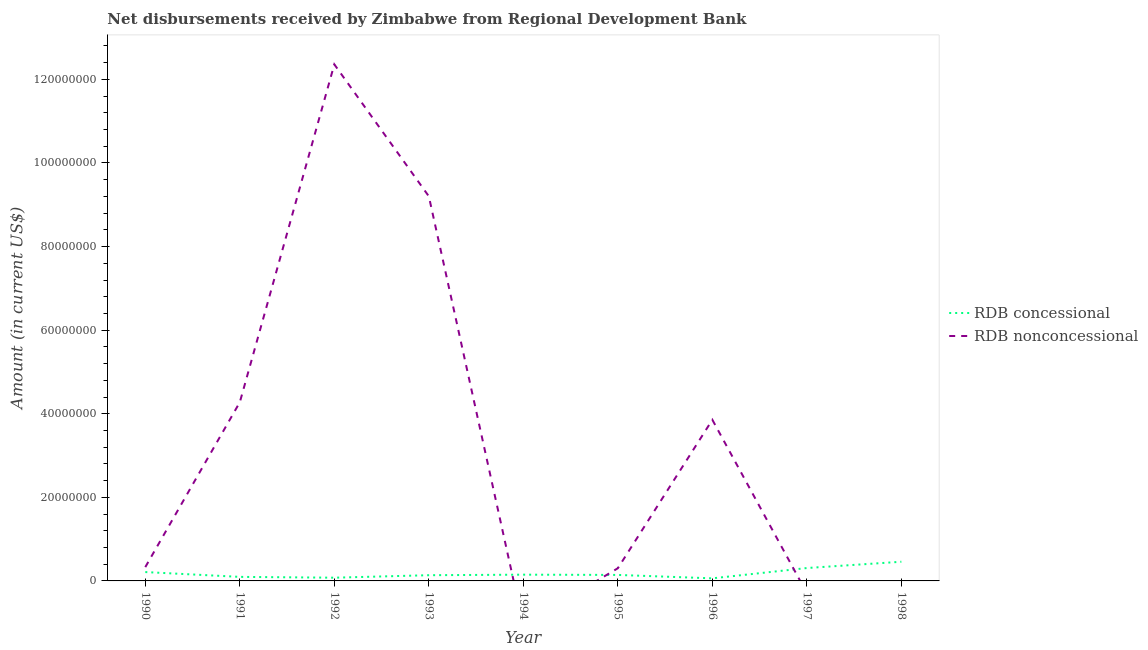How many different coloured lines are there?
Your answer should be compact. 2. Does the line corresponding to net concessional disbursements from rdb intersect with the line corresponding to net non concessional disbursements from rdb?
Provide a short and direct response. Yes. Is the number of lines equal to the number of legend labels?
Ensure brevity in your answer.  No. What is the net non concessional disbursements from rdb in 1990?
Your answer should be very brief. 3.30e+06. Across all years, what is the maximum net non concessional disbursements from rdb?
Give a very brief answer. 1.24e+08. What is the total net concessional disbursements from rdb in the graph?
Your answer should be very brief. 1.64e+07. What is the difference between the net non concessional disbursements from rdb in 1992 and that in 1995?
Your response must be concise. 1.21e+08. What is the difference between the net concessional disbursements from rdb in 1997 and the net non concessional disbursements from rdb in 1998?
Your answer should be compact. 3.08e+06. What is the average net concessional disbursements from rdb per year?
Ensure brevity in your answer.  1.83e+06. In the year 1991, what is the difference between the net non concessional disbursements from rdb and net concessional disbursements from rdb?
Provide a short and direct response. 4.18e+07. What is the ratio of the net non concessional disbursements from rdb in 1990 to that in 1993?
Offer a terse response. 0.04. Is the difference between the net concessional disbursements from rdb in 1990 and 1996 greater than the difference between the net non concessional disbursements from rdb in 1990 and 1996?
Make the answer very short. Yes. What is the difference between the highest and the second highest net non concessional disbursements from rdb?
Ensure brevity in your answer.  3.16e+07. What is the difference between the highest and the lowest net concessional disbursements from rdb?
Provide a succinct answer. 3.97e+06. In how many years, is the net non concessional disbursements from rdb greater than the average net non concessional disbursements from rdb taken over all years?
Give a very brief answer. 4. Is the net non concessional disbursements from rdb strictly less than the net concessional disbursements from rdb over the years?
Offer a terse response. No. How many lines are there?
Offer a terse response. 2. How many years are there in the graph?
Make the answer very short. 9. What is the difference between two consecutive major ticks on the Y-axis?
Offer a very short reply. 2.00e+07. Does the graph contain grids?
Keep it short and to the point. No. Where does the legend appear in the graph?
Give a very brief answer. Center right. How are the legend labels stacked?
Your response must be concise. Vertical. What is the title of the graph?
Provide a succinct answer. Net disbursements received by Zimbabwe from Regional Development Bank. Does "Nitrous oxide" appear as one of the legend labels in the graph?
Provide a short and direct response. No. What is the label or title of the X-axis?
Give a very brief answer. Year. What is the label or title of the Y-axis?
Your response must be concise. Amount (in current US$). What is the Amount (in current US$) of RDB concessional in 1990?
Your answer should be compact. 2.12e+06. What is the Amount (in current US$) of RDB nonconcessional in 1990?
Offer a terse response. 3.30e+06. What is the Amount (in current US$) of RDB concessional in 1991?
Your answer should be compact. 9.67e+05. What is the Amount (in current US$) in RDB nonconcessional in 1991?
Offer a terse response. 4.27e+07. What is the Amount (in current US$) of RDB concessional in 1992?
Provide a short and direct response. 7.71e+05. What is the Amount (in current US$) in RDB nonconcessional in 1992?
Offer a terse response. 1.24e+08. What is the Amount (in current US$) in RDB concessional in 1993?
Offer a very short reply. 1.37e+06. What is the Amount (in current US$) in RDB nonconcessional in 1993?
Make the answer very short. 9.20e+07. What is the Amount (in current US$) of RDB concessional in 1994?
Give a very brief answer. 1.50e+06. What is the Amount (in current US$) of RDB nonconcessional in 1994?
Keep it short and to the point. 0. What is the Amount (in current US$) in RDB concessional in 1995?
Offer a very short reply. 1.43e+06. What is the Amount (in current US$) of RDB nonconcessional in 1995?
Provide a succinct answer. 3.04e+06. What is the Amount (in current US$) in RDB concessional in 1996?
Make the answer very short. 6.17e+05. What is the Amount (in current US$) in RDB nonconcessional in 1996?
Your response must be concise. 3.86e+07. What is the Amount (in current US$) in RDB concessional in 1997?
Your response must be concise. 3.08e+06. What is the Amount (in current US$) in RDB concessional in 1998?
Give a very brief answer. 4.59e+06. What is the Amount (in current US$) of RDB nonconcessional in 1998?
Provide a short and direct response. 0. Across all years, what is the maximum Amount (in current US$) in RDB concessional?
Offer a terse response. 4.59e+06. Across all years, what is the maximum Amount (in current US$) in RDB nonconcessional?
Provide a short and direct response. 1.24e+08. Across all years, what is the minimum Amount (in current US$) of RDB concessional?
Ensure brevity in your answer.  6.17e+05. What is the total Amount (in current US$) of RDB concessional in the graph?
Your answer should be compact. 1.64e+07. What is the total Amount (in current US$) of RDB nonconcessional in the graph?
Keep it short and to the point. 3.03e+08. What is the difference between the Amount (in current US$) of RDB concessional in 1990 and that in 1991?
Provide a succinct answer. 1.15e+06. What is the difference between the Amount (in current US$) of RDB nonconcessional in 1990 and that in 1991?
Provide a short and direct response. -3.94e+07. What is the difference between the Amount (in current US$) in RDB concessional in 1990 and that in 1992?
Provide a succinct answer. 1.35e+06. What is the difference between the Amount (in current US$) of RDB nonconcessional in 1990 and that in 1992?
Keep it short and to the point. -1.20e+08. What is the difference between the Amount (in current US$) of RDB concessional in 1990 and that in 1993?
Offer a very short reply. 7.51e+05. What is the difference between the Amount (in current US$) of RDB nonconcessional in 1990 and that in 1993?
Your response must be concise. -8.87e+07. What is the difference between the Amount (in current US$) of RDB concessional in 1990 and that in 1994?
Make the answer very short. 6.24e+05. What is the difference between the Amount (in current US$) of RDB concessional in 1990 and that in 1995?
Your answer should be compact. 6.86e+05. What is the difference between the Amount (in current US$) in RDB nonconcessional in 1990 and that in 1995?
Make the answer very short. 2.67e+05. What is the difference between the Amount (in current US$) of RDB concessional in 1990 and that in 1996?
Your answer should be compact. 1.50e+06. What is the difference between the Amount (in current US$) in RDB nonconcessional in 1990 and that in 1996?
Your response must be concise. -3.52e+07. What is the difference between the Amount (in current US$) in RDB concessional in 1990 and that in 1997?
Provide a succinct answer. -9.65e+05. What is the difference between the Amount (in current US$) in RDB concessional in 1990 and that in 1998?
Your response must be concise. -2.47e+06. What is the difference between the Amount (in current US$) in RDB concessional in 1991 and that in 1992?
Offer a terse response. 1.96e+05. What is the difference between the Amount (in current US$) of RDB nonconcessional in 1991 and that in 1992?
Your response must be concise. -8.08e+07. What is the difference between the Amount (in current US$) in RDB concessional in 1991 and that in 1993?
Your answer should be compact. -4.02e+05. What is the difference between the Amount (in current US$) in RDB nonconcessional in 1991 and that in 1993?
Offer a terse response. -4.93e+07. What is the difference between the Amount (in current US$) of RDB concessional in 1991 and that in 1994?
Your answer should be very brief. -5.29e+05. What is the difference between the Amount (in current US$) in RDB concessional in 1991 and that in 1995?
Your answer should be compact. -4.67e+05. What is the difference between the Amount (in current US$) of RDB nonconcessional in 1991 and that in 1995?
Make the answer very short. 3.97e+07. What is the difference between the Amount (in current US$) of RDB nonconcessional in 1991 and that in 1996?
Provide a short and direct response. 4.20e+06. What is the difference between the Amount (in current US$) in RDB concessional in 1991 and that in 1997?
Your answer should be very brief. -2.12e+06. What is the difference between the Amount (in current US$) of RDB concessional in 1991 and that in 1998?
Make the answer very short. -3.62e+06. What is the difference between the Amount (in current US$) of RDB concessional in 1992 and that in 1993?
Make the answer very short. -5.98e+05. What is the difference between the Amount (in current US$) of RDB nonconcessional in 1992 and that in 1993?
Provide a short and direct response. 3.16e+07. What is the difference between the Amount (in current US$) in RDB concessional in 1992 and that in 1994?
Your answer should be compact. -7.25e+05. What is the difference between the Amount (in current US$) of RDB concessional in 1992 and that in 1995?
Give a very brief answer. -6.63e+05. What is the difference between the Amount (in current US$) of RDB nonconcessional in 1992 and that in 1995?
Keep it short and to the point. 1.21e+08. What is the difference between the Amount (in current US$) in RDB concessional in 1992 and that in 1996?
Make the answer very short. 1.54e+05. What is the difference between the Amount (in current US$) of RDB nonconcessional in 1992 and that in 1996?
Provide a short and direct response. 8.50e+07. What is the difference between the Amount (in current US$) in RDB concessional in 1992 and that in 1997?
Give a very brief answer. -2.31e+06. What is the difference between the Amount (in current US$) of RDB concessional in 1992 and that in 1998?
Keep it short and to the point. -3.82e+06. What is the difference between the Amount (in current US$) in RDB concessional in 1993 and that in 1994?
Offer a terse response. -1.27e+05. What is the difference between the Amount (in current US$) of RDB concessional in 1993 and that in 1995?
Your response must be concise. -6.50e+04. What is the difference between the Amount (in current US$) in RDB nonconcessional in 1993 and that in 1995?
Provide a succinct answer. 8.90e+07. What is the difference between the Amount (in current US$) of RDB concessional in 1993 and that in 1996?
Keep it short and to the point. 7.52e+05. What is the difference between the Amount (in current US$) in RDB nonconcessional in 1993 and that in 1996?
Your answer should be very brief. 5.35e+07. What is the difference between the Amount (in current US$) in RDB concessional in 1993 and that in 1997?
Keep it short and to the point. -1.72e+06. What is the difference between the Amount (in current US$) of RDB concessional in 1993 and that in 1998?
Your response must be concise. -3.22e+06. What is the difference between the Amount (in current US$) in RDB concessional in 1994 and that in 1995?
Your answer should be compact. 6.20e+04. What is the difference between the Amount (in current US$) of RDB concessional in 1994 and that in 1996?
Offer a terse response. 8.79e+05. What is the difference between the Amount (in current US$) in RDB concessional in 1994 and that in 1997?
Keep it short and to the point. -1.59e+06. What is the difference between the Amount (in current US$) in RDB concessional in 1994 and that in 1998?
Your answer should be compact. -3.09e+06. What is the difference between the Amount (in current US$) in RDB concessional in 1995 and that in 1996?
Offer a terse response. 8.17e+05. What is the difference between the Amount (in current US$) of RDB nonconcessional in 1995 and that in 1996?
Your answer should be very brief. -3.55e+07. What is the difference between the Amount (in current US$) in RDB concessional in 1995 and that in 1997?
Keep it short and to the point. -1.65e+06. What is the difference between the Amount (in current US$) in RDB concessional in 1995 and that in 1998?
Provide a short and direct response. -3.16e+06. What is the difference between the Amount (in current US$) of RDB concessional in 1996 and that in 1997?
Offer a terse response. -2.47e+06. What is the difference between the Amount (in current US$) of RDB concessional in 1996 and that in 1998?
Ensure brevity in your answer.  -3.97e+06. What is the difference between the Amount (in current US$) of RDB concessional in 1997 and that in 1998?
Provide a short and direct response. -1.50e+06. What is the difference between the Amount (in current US$) of RDB concessional in 1990 and the Amount (in current US$) of RDB nonconcessional in 1991?
Your answer should be compact. -4.06e+07. What is the difference between the Amount (in current US$) of RDB concessional in 1990 and the Amount (in current US$) of RDB nonconcessional in 1992?
Your response must be concise. -1.21e+08. What is the difference between the Amount (in current US$) of RDB concessional in 1990 and the Amount (in current US$) of RDB nonconcessional in 1993?
Offer a very short reply. -8.99e+07. What is the difference between the Amount (in current US$) in RDB concessional in 1990 and the Amount (in current US$) in RDB nonconcessional in 1995?
Provide a short and direct response. -9.17e+05. What is the difference between the Amount (in current US$) in RDB concessional in 1990 and the Amount (in current US$) in RDB nonconcessional in 1996?
Provide a short and direct response. -3.64e+07. What is the difference between the Amount (in current US$) of RDB concessional in 1991 and the Amount (in current US$) of RDB nonconcessional in 1992?
Provide a succinct answer. -1.23e+08. What is the difference between the Amount (in current US$) in RDB concessional in 1991 and the Amount (in current US$) in RDB nonconcessional in 1993?
Offer a very short reply. -9.11e+07. What is the difference between the Amount (in current US$) in RDB concessional in 1991 and the Amount (in current US$) in RDB nonconcessional in 1995?
Provide a succinct answer. -2.07e+06. What is the difference between the Amount (in current US$) of RDB concessional in 1991 and the Amount (in current US$) of RDB nonconcessional in 1996?
Your answer should be very brief. -3.76e+07. What is the difference between the Amount (in current US$) in RDB concessional in 1992 and the Amount (in current US$) in RDB nonconcessional in 1993?
Your answer should be compact. -9.13e+07. What is the difference between the Amount (in current US$) of RDB concessional in 1992 and the Amount (in current US$) of RDB nonconcessional in 1995?
Your answer should be very brief. -2.27e+06. What is the difference between the Amount (in current US$) in RDB concessional in 1992 and the Amount (in current US$) in RDB nonconcessional in 1996?
Ensure brevity in your answer.  -3.78e+07. What is the difference between the Amount (in current US$) in RDB concessional in 1993 and the Amount (in current US$) in RDB nonconcessional in 1995?
Offer a terse response. -1.67e+06. What is the difference between the Amount (in current US$) of RDB concessional in 1993 and the Amount (in current US$) of RDB nonconcessional in 1996?
Make the answer very short. -3.72e+07. What is the difference between the Amount (in current US$) in RDB concessional in 1994 and the Amount (in current US$) in RDB nonconcessional in 1995?
Keep it short and to the point. -1.54e+06. What is the difference between the Amount (in current US$) in RDB concessional in 1994 and the Amount (in current US$) in RDB nonconcessional in 1996?
Provide a succinct answer. -3.71e+07. What is the difference between the Amount (in current US$) of RDB concessional in 1995 and the Amount (in current US$) of RDB nonconcessional in 1996?
Offer a very short reply. -3.71e+07. What is the average Amount (in current US$) of RDB concessional per year?
Provide a short and direct response. 1.83e+06. What is the average Amount (in current US$) in RDB nonconcessional per year?
Offer a terse response. 3.37e+07. In the year 1990, what is the difference between the Amount (in current US$) of RDB concessional and Amount (in current US$) of RDB nonconcessional?
Your response must be concise. -1.18e+06. In the year 1991, what is the difference between the Amount (in current US$) in RDB concessional and Amount (in current US$) in RDB nonconcessional?
Your answer should be compact. -4.18e+07. In the year 1992, what is the difference between the Amount (in current US$) of RDB concessional and Amount (in current US$) of RDB nonconcessional?
Offer a very short reply. -1.23e+08. In the year 1993, what is the difference between the Amount (in current US$) of RDB concessional and Amount (in current US$) of RDB nonconcessional?
Offer a very short reply. -9.07e+07. In the year 1995, what is the difference between the Amount (in current US$) of RDB concessional and Amount (in current US$) of RDB nonconcessional?
Offer a terse response. -1.60e+06. In the year 1996, what is the difference between the Amount (in current US$) in RDB concessional and Amount (in current US$) in RDB nonconcessional?
Offer a very short reply. -3.79e+07. What is the ratio of the Amount (in current US$) in RDB concessional in 1990 to that in 1991?
Provide a succinct answer. 2.19. What is the ratio of the Amount (in current US$) in RDB nonconcessional in 1990 to that in 1991?
Make the answer very short. 0.08. What is the ratio of the Amount (in current US$) in RDB concessional in 1990 to that in 1992?
Keep it short and to the point. 2.75. What is the ratio of the Amount (in current US$) of RDB nonconcessional in 1990 to that in 1992?
Your answer should be compact. 0.03. What is the ratio of the Amount (in current US$) in RDB concessional in 1990 to that in 1993?
Provide a succinct answer. 1.55. What is the ratio of the Amount (in current US$) in RDB nonconcessional in 1990 to that in 1993?
Keep it short and to the point. 0.04. What is the ratio of the Amount (in current US$) of RDB concessional in 1990 to that in 1994?
Make the answer very short. 1.42. What is the ratio of the Amount (in current US$) of RDB concessional in 1990 to that in 1995?
Your answer should be very brief. 1.48. What is the ratio of the Amount (in current US$) of RDB nonconcessional in 1990 to that in 1995?
Offer a very short reply. 1.09. What is the ratio of the Amount (in current US$) of RDB concessional in 1990 to that in 1996?
Provide a succinct answer. 3.44. What is the ratio of the Amount (in current US$) of RDB nonconcessional in 1990 to that in 1996?
Your response must be concise. 0.09. What is the ratio of the Amount (in current US$) of RDB concessional in 1990 to that in 1997?
Your answer should be very brief. 0.69. What is the ratio of the Amount (in current US$) in RDB concessional in 1990 to that in 1998?
Give a very brief answer. 0.46. What is the ratio of the Amount (in current US$) of RDB concessional in 1991 to that in 1992?
Offer a terse response. 1.25. What is the ratio of the Amount (in current US$) of RDB nonconcessional in 1991 to that in 1992?
Your answer should be compact. 0.35. What is the ratio of the Amount (in current US$) of RDB concessional in 1991 to that in 1993?
Give a very brief answer. 0.71. What is the ratio of the Amount (in current US$) of RDB nonconcessional in 1991 to that in 1993?
Your answer should be compact. 0.46. What is the ratio of the Amount (in current US$) of RDB concessional in 1991 to that in 1994?
Your answer should be very brief. 0.65. What is the ratio of the Amount (in current US$) of RDB concessional in 1991 to that in 1995?
Keep it short and to the point. 0.67. What is the ratio of the Amount (in current US$) in RDB nonconcessional in 1991 to that in 1995?
Give a very brief answer. 14.08. What is the ratio of the Amount (in current US$) in RDB concessional in 1991 to that in 1996?
Provide a short and direct response. 1.57. What is the ratio of the Amount (in current US$) in RDB nonconcessional in 1991 to that in 1996?
Offer a terse response. 1.11. What is the ratio of the Amount (in current US$) in RDB concessional in 1991 to that in 1997?
Keep it short and to the point. 0.31. What is the ratio of the Amount (in current US$) in RDB concessional in 1991 to that in 1998?
Offer a terse response. 0.21. What is the ratio of the Amount (in current US$) in RDB concessional in 1992 to that in 1993?
Make the answer very short. 0.56. What is the ratio of the Amount (in current US$) of RDB nonconcessional in 1992 to that in 1993?
Keep it short and to the point. 1.34. What is the ratio of the Amount (in current US$) in RDB concessional in 1992 to that in 1994?
Ensure brevity in your answer.  0.52. What is the ratio of the Amount (in current US$) in RDB concessional in 1992 to that in 1995?
Offer a very short reply. 0.54. What is the ratio of the Amount (in current US$) of RDB nonconcessional in 1992 to that in 1995?
Keep it short and to the point. 40.7. What is the ratio of the Amount (in current US$) of RDB concessional in 1992 to that in 1996?
Your answer should be compact. 1.25. What is the ratio of the Amount (in current US$) in RDB nonconcessional in 1992 to that in 1996?
Your answer should be very brief. 3.21. What is the ratio of the Amount (in current US$) in RDB concessional in 1992 to that in 1997?
Offer a terse response. 0.25. What is the ratio of the Amount (in current US$) of RDB concessional in 1992 to that in 1998?
Provide a succinct answer. 0.17. What is the ratio of the Amount (in current US$) in RDB concessional in 1993 to that in 1994?
Give a very brief answer. 0.92. What is the ratio of the Amount (in current US$) in RDB concessional in 1993 to that in 1995?
Your answer should be very brief. 0.95. What is the ratio of the Amount (in current US$) of RDB nonconcessional in 1993 to that in 1995?
Offer a very short reply. 30.3. What is the ratio of the Amount (in current US$) in RDB concessional in 1993 to that in 1996?
Give a very brief answer. 2.22. What is the ratio of the Amount (in current US$) of RDB nonconcessional in 1993 to that in 1996?
Ensure brevity in your answer.  2.39. What is the ratio of the Amount (in current US$) in RDB concessional in 1993 to that in 1997?
Offer a very short reply. 0.44. What is the ratio of the Amount (in current US$) in RDB concessional in 1993 to that in 1998?
Give a very brief answer. 0.3. What is the ratio of the Amount (in current US$) of RDB concessional in 1994 to that in 1995?
Offer a terse response. 1.04. What is the ratio of the Amount (in current US$) of RDB concessional in 1994 to that in 1996?
Your answer should be compact. 2.42. What is the ratio of the Amount (in current US$) of RDB concessional in 1994 to that in 1997?
Provide a succinct answer. 0.48. What is the ratio of the Amount (in current US$) in RDB concessional in 1994 to that in 1998?
Your answer should be compact. 0.33. What is the ratio of the Amount (in current US$) of RDB concessional in 1995 to that in 1996?
Give a very brief answer. 2.32. What is the ratio of the Amount (in current US$) of RDB nonconcessional in 1995 to that in 1996?
Give a very brief answer. 0.08. What is the ratio of the Amount (in current US$) of RDB concessional in 1995 to that in 1997?
Give a very brief answer. 0.46. What is the ratio of the Amount (in current US$) in RDB concessional in 1995 to that in 1998?
Keep it short and to the point. 0.31. What is the ratio of the Amount (in current US$) of RDB concessional in 1996 to that in 1997?
Keep it short and to the point. 0.2. What is the ratio of the Amount (in current US$) in RDB concessional in 1996 to that in 1998?
Your answer should be compact. 0.13. What is the ratio of the Amount (in current US$) of RDB concessional in 1997 to that in 1998?
Provide a succinct answer. 0.67. What is the difference between the highest and the second highest Amount (in current US$) in RDB concessional?
Your answer should be compact. 1.50e+06. What is the difference between the highest and the second highest Amount (in current US$) of RDB nonconcessional?
Ensure brevity in your answer.  3.16e+07. What is the difference between the highest and the lowest Amount (in current US$) of RDB concessional?
Keep it short and to the point. 3.97e+06. What is the difference between the highest and the lowest Amount (in current US$) of RDB nonconcessional?
Keep it short and to the point. 1.24e+08. 